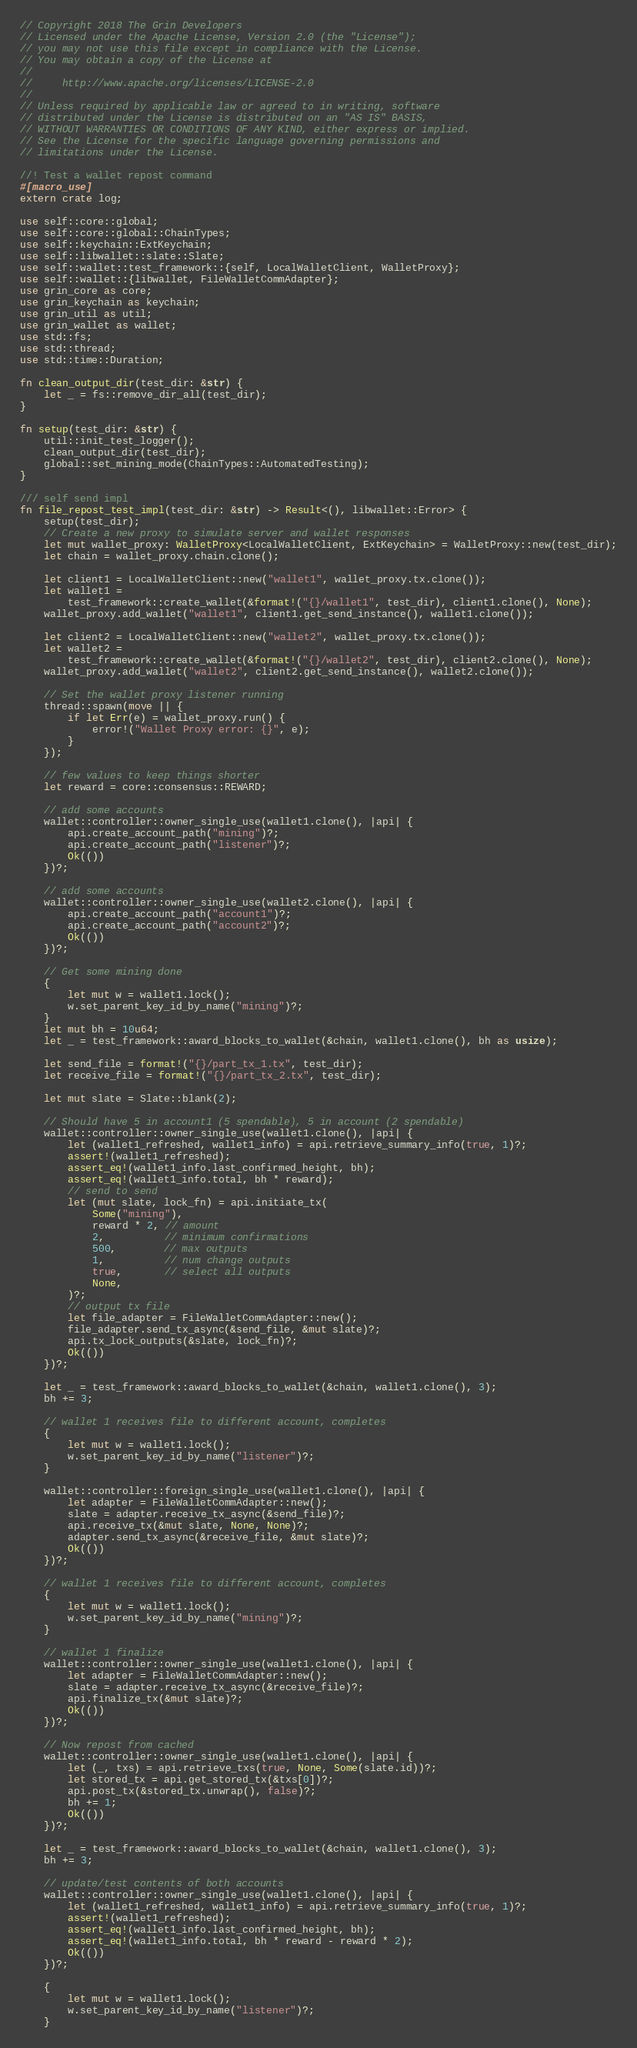Convert code to text. <code><loc_0><loc_0><loc_500><loc_500><_Rust_>// Copyright 2018 The Grin Developers
// Licensed under the Apache License, Version 2.0 (the "License");
// you may not use this file except in compliance with the License.
// You may obtain a copy of the License at
//
//     http://www.apache.org/licenses/LICENSE-2.0
//
// Unless required by applicable law or agreed to in writing, software
// distributed under the License is distributed on an "AS IS" BASIS,
// WITHOUT WARRANTIES OR CONDITIONS OF ANY KIND, either express or implied.
// See the License for the specific language governing permissions and
// limitations under the License.

//! Test a wallet repost command
#[macro_use]
extern crate log;

use self::core::global;
use self::core::global::ChainTypes;
use self::keychain::ExtKeychain;
use self::libwallet::slate::Slate;
use self::wallet::test_framework::{self, LocalWalletClient, WalletProxy};
use self::wallet::{libwallet, FileWalletCommAdapter};
use grin_core as core;
use grin_keychain as keychain;
use grin_util as util;
use grin_wallet as wallet;
use std::fs;
use std::thread;
use std::time::Duration;

fn clean_output_dir(test_dir: &str) {
	let _ = fs::remove_dir_all(test_dir);
}

fn setup(test_dir: &str) {
	util::init_test_logger();
	clean_output_dir(test_dir);
	global::set_mining_mode(ChainTypes::AutomatedTesting);
}

/// self send impl
fn file_repost_test_impl(test_dir: &str) -> Result<(), libwallet::Error> {
	setup(test_dir);
	// Create a new proxy to simulate server and wallet responses
	let mut wallet_proxy: WalletProxy<LocalWalletClient, ExtKeychain> = WalletProxy::new(test_dir);
	let chain = wallet_proxy.chain.clone();

	let client1 = LocalWalletClient::new("wallet1", wallet_proxy.tx.clone());
	let wallet1 =
		test_framework::create_wallet(&format!("{}/wallet1", test_dir), client1.clone(), None);
	wallet_proxy.add_wallet("wallet1", client1.get_send_instance(), wallet1.clone());

	let client2 = LocalWalletClient::new("wallet2", wallet_proxy.tx.clone());
	let wallet2 =
		test_framework::create_wallet(&format!("{}/wallet2", test_dir), client2.clone(), None);
	wallet_proxy.add_wallet("wallet2", client2.get_send_instance(), wallet2.clone());

	// Set the wallet proxy listener running
	thread::spawn(move || {
		if let Err(e) = wallet_proxy.run() {
			error!("Wallet Proxy error: {}", e);
		}
	});

	// few values to keep things shorter
	let reward = core::consensus::REWARD;

	// add some accounts
	wallet::controller::owner_single_use(wallet1.clone(), |api| {
		api.create_account_path("mining")?;
		api.create_account_path("listener")?;
		Ok(())
	})?;

	// add some accounts
	wallet::controller::owner_single_use(wallet2.clone(), |api| {
		api.create_account_path("account1")?;
		api.create_account_path("account2")?;
		Ok(())
	})?;

	// Get some mining done
	{
		let mut w = wallet1.lock();
		w.set_parent_key_id_by_name("mining")?;
	}
	let mut bh = 10u64;
	let _ = test_framework::award_blocks_to_wallet(&chain, wallet1.clone(), bh as usize);

	let send_file = format!("{}/part_tx_1.tx", test_dir);
	let receive_file = format!("{}/part_tx_2.tx", test_dir);

	let mut slate = Slate::blank(2);

	// Should have 5 in account1 (5 spendable), 5 in account (2 spendable)
	wallet::controller::owner_single_use(wallet1.clone(), |api| {
		let (wallet1_refreshed, wallet1_info) = api.retrieve_summary_info(true, 1)?;
		assert!(wallet1_refreshed);
		assert_eq!(wallet1_info.last_confirmed_height, bh);
		assert_eq!(wallet1_info.total, bh * reward);
		// send to send
		let (mut slate, lock_fn) = api.initiate_tx(
			Some("mining"),
			reward * 2, // amount
			2,          // minimum confirmations
			500,        // max outputs
			1,          // num change outputs
			true,       // select all outputs
			None,
		)?;
		// output tx file
		let file_adapter = FileWalletCommAdapter::new();
		file_adapter.send_tx_async(&send_file, &mut slate)?;
		api.tx_lock_outputs(&slate, lock_fn)?;
		Ok(())
	})?;

	let _ = test_framework::award_blocks_to_wallet(&chain, wallet1.clone(), 3);
	bh += 3;

	// wallet 1 receives file to different account, completes
	{
		let mut w = wallet1.lock();
		w.set_parent_key_id_by_name("listener")?;
	}

	wallet::controller::foreign_single_use(wallet1.clone(), |api| {
		let adapter = FileWalletCommAdapter::new();
		slate = adapter.receive_tx_async(&send_file)?;
		api.receive_tx(&mut slate, None, None)?;
		adapter.send_tx_async(&receive_file, &mut slate)?;
		Ok(())
	})?;

	// wallet 1 receives file to different account, completes
	{
		let mut w = wallet1.lock();
		w.set_parent_key_id_by_name("mining")?;
	}

	// wallet 1 finalize
	wallet::controller::owner_single_use(wallet1.clone(), |api| {
		let adapter = FileWalletCommAdapter::new();
		slate = adapter.receive_tx_async(&receive_file)?;
		api.finalize_tx(&mut slate)?;
		Ok(())
	})?;

	// Now repost from cached
	wallet::controller::owner_single_use(wallet1.clone(), |api| {
		let (_, txs) = api.retrieve_txs(true, None, Some(slate.id))?;
		let stored_tx = api.get_stored_tx(&txs[0])?;
		api.post_tx(&stored_tx.unwrap(), false)?;
		bh += 1;
		Ok(())
	})?;

	let _ = test_framework::award_blocks_to_wallet(&chain, wallet1.clone(), 3);
	bh += 3;

	// update/test contents of both accounts
	wallet::controller::owner_single_use(wallet1.clone(), |api| {
		let (wallet1_refreshed, wallet1_info) = api.retrieve_summary_info(true, 1)?;
		assert!(wallet1_refreshed);
		assert_eq!(wallet1_info.last_confirmed_height, bh);
		assert_eq!(wallet1_info.total, bh * reward - reward * 2);
		Ok(())
	})?;

	{
		let mut w = wallet1.lock();
		w.set_parent_key_id_by_name("listener")?;
	}
</code> 